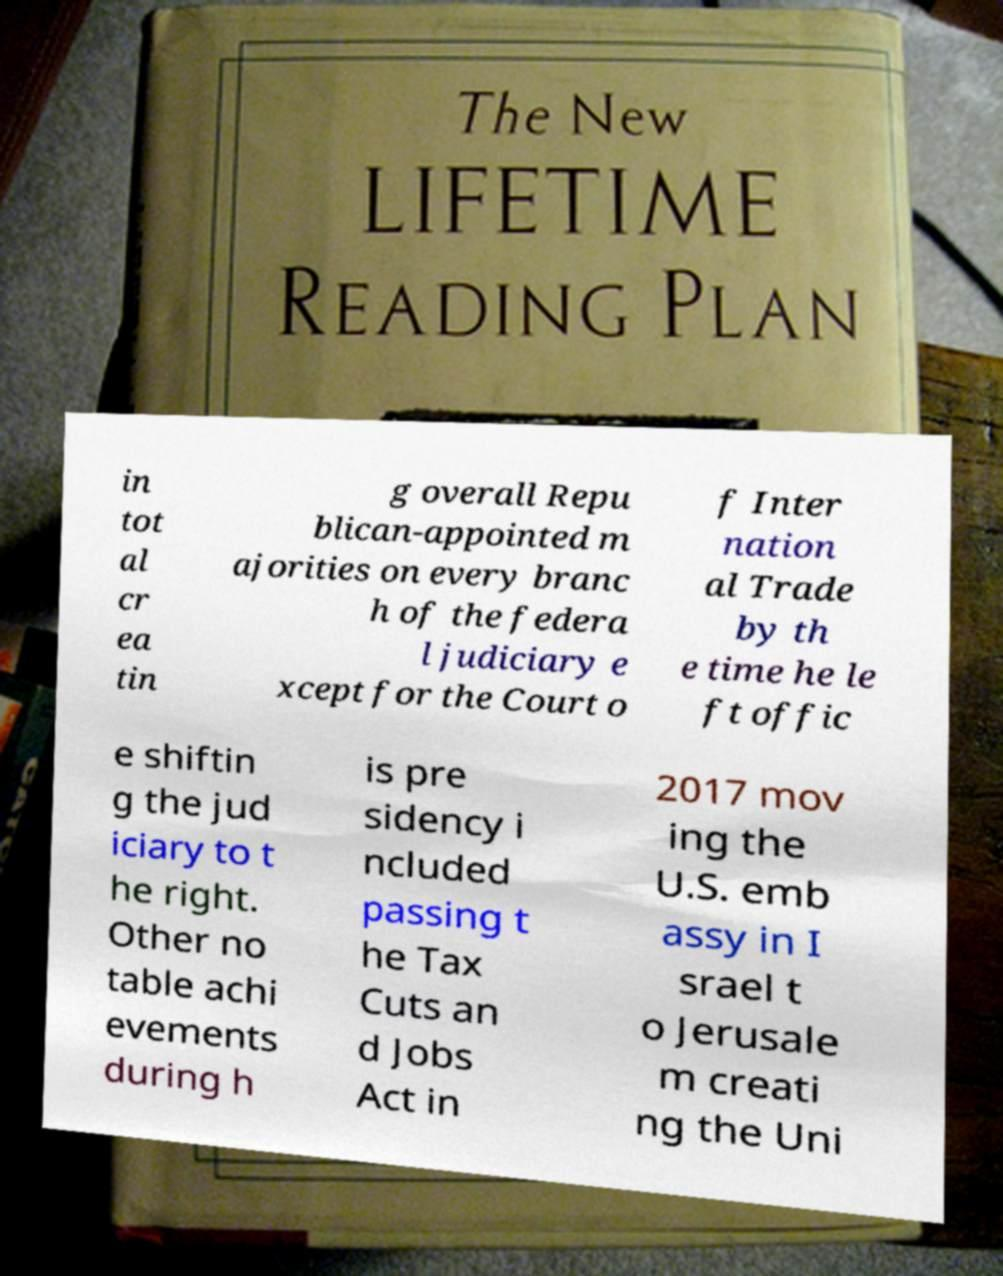Please read and relay the text visible in this image. What does it say? in tot al cr ea tin g overall Repu blican-appointed m ajorities on every branc h of the federa l judiciary e xcept for the Court o f Inter nation al Trade by th e time he le ft offic e shiftin g the jud iciary to t he right. Other no table achi evements during h is pre sidency i ncluded passing t he Tax Cuts an d Jobs Act in 2017 mov ing the U.S. emb assy in I srael t o Jerusale m creati ng the Uni 